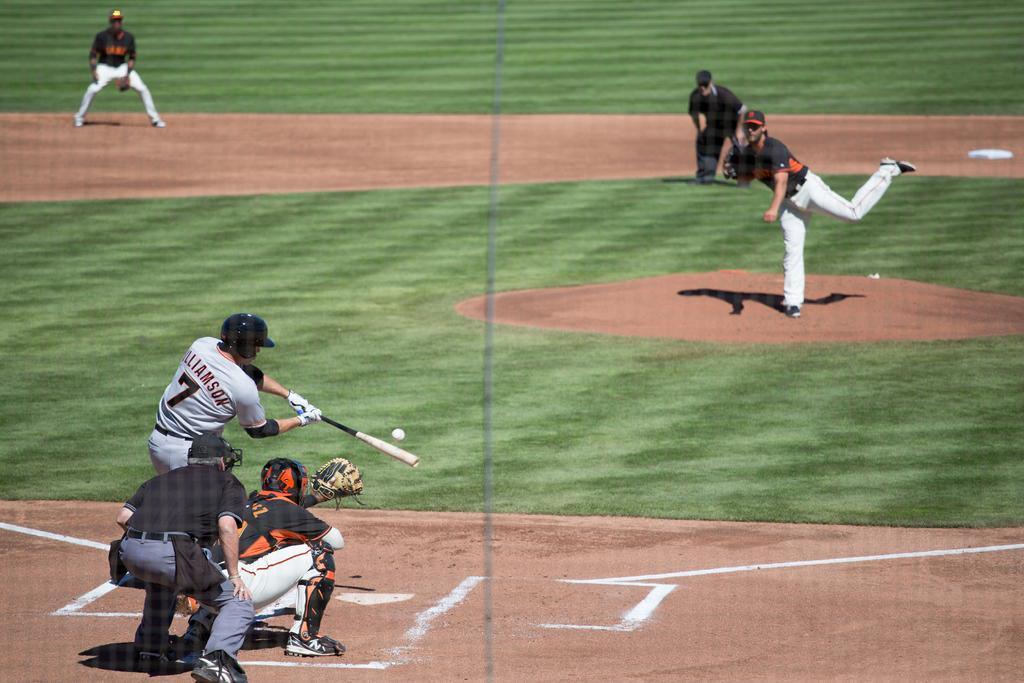Can you describe this image briefly? This is a playground. In this picture we can see the people playing baseball. We can see a man wearing a helmet, gloves, holding a baseball bat. We can see a ball in the air. 